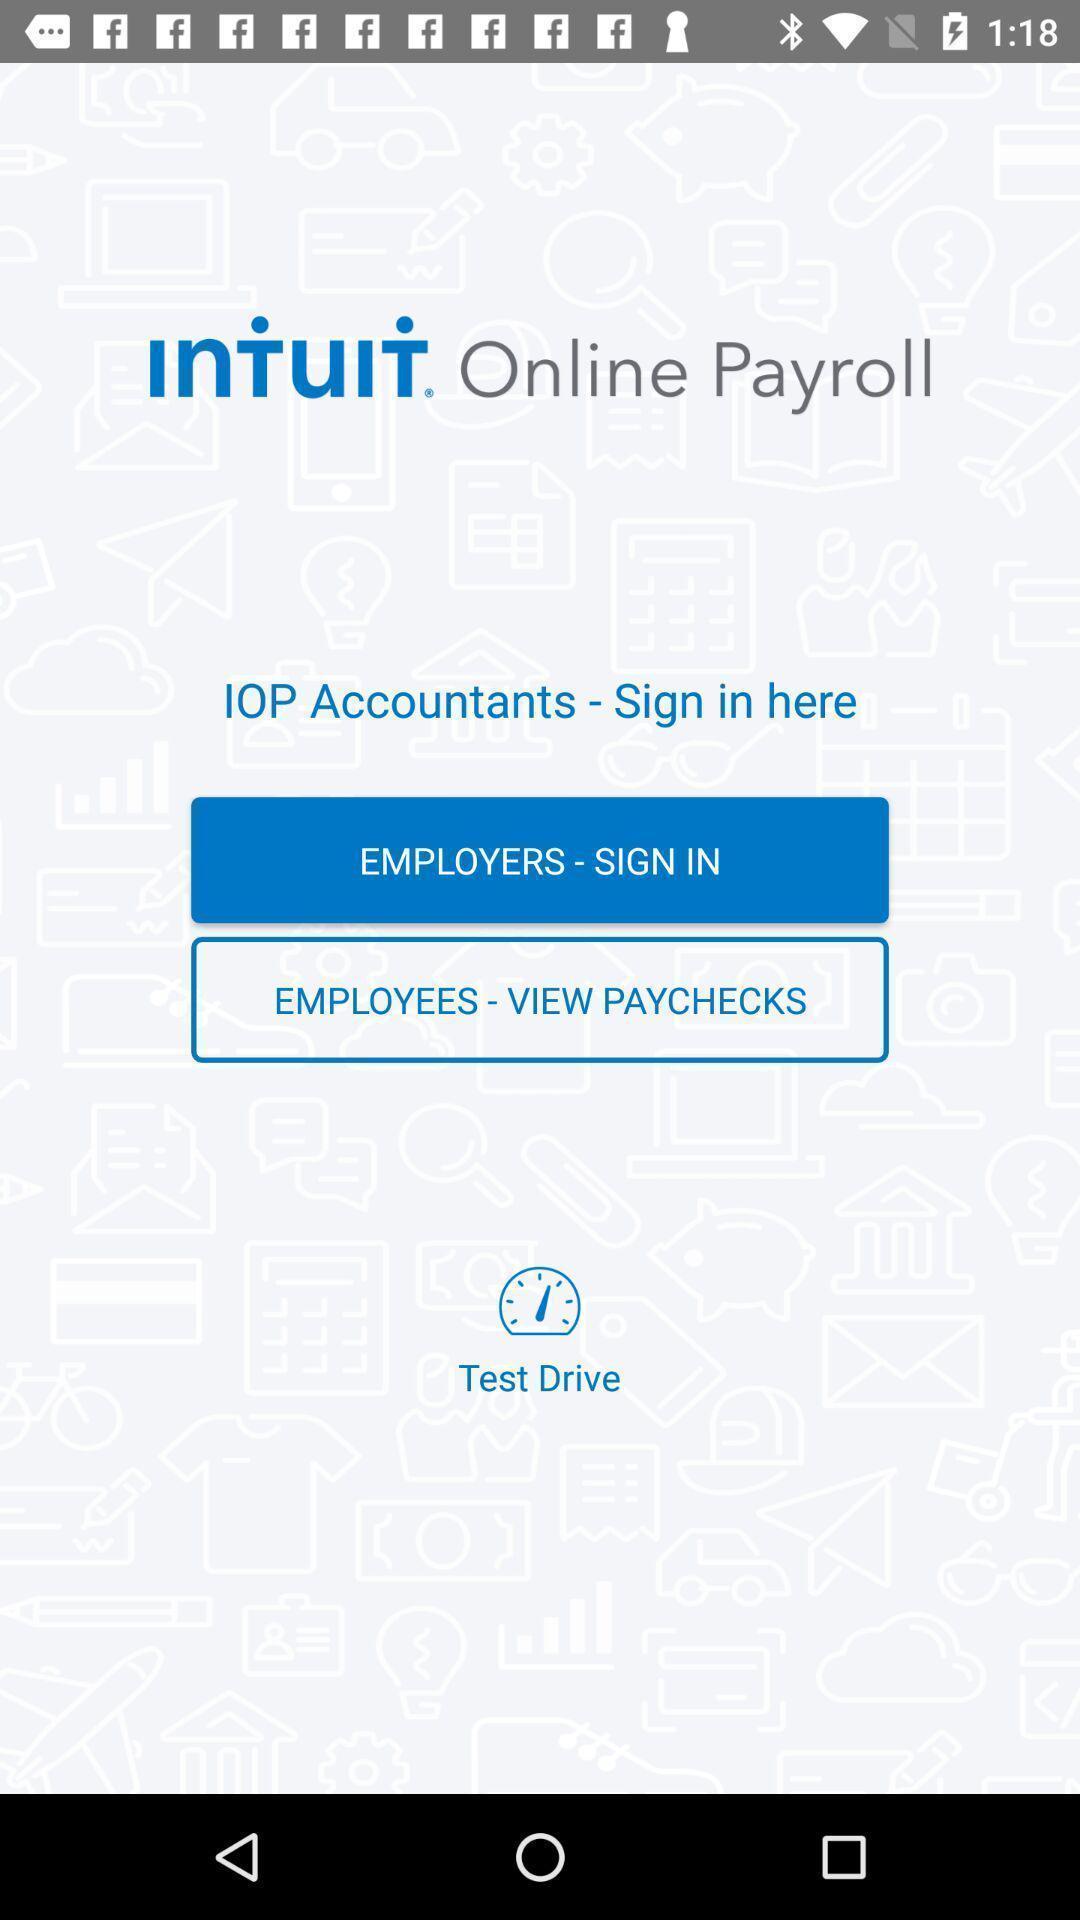Summarize the main components in this picture. Welcome page. 